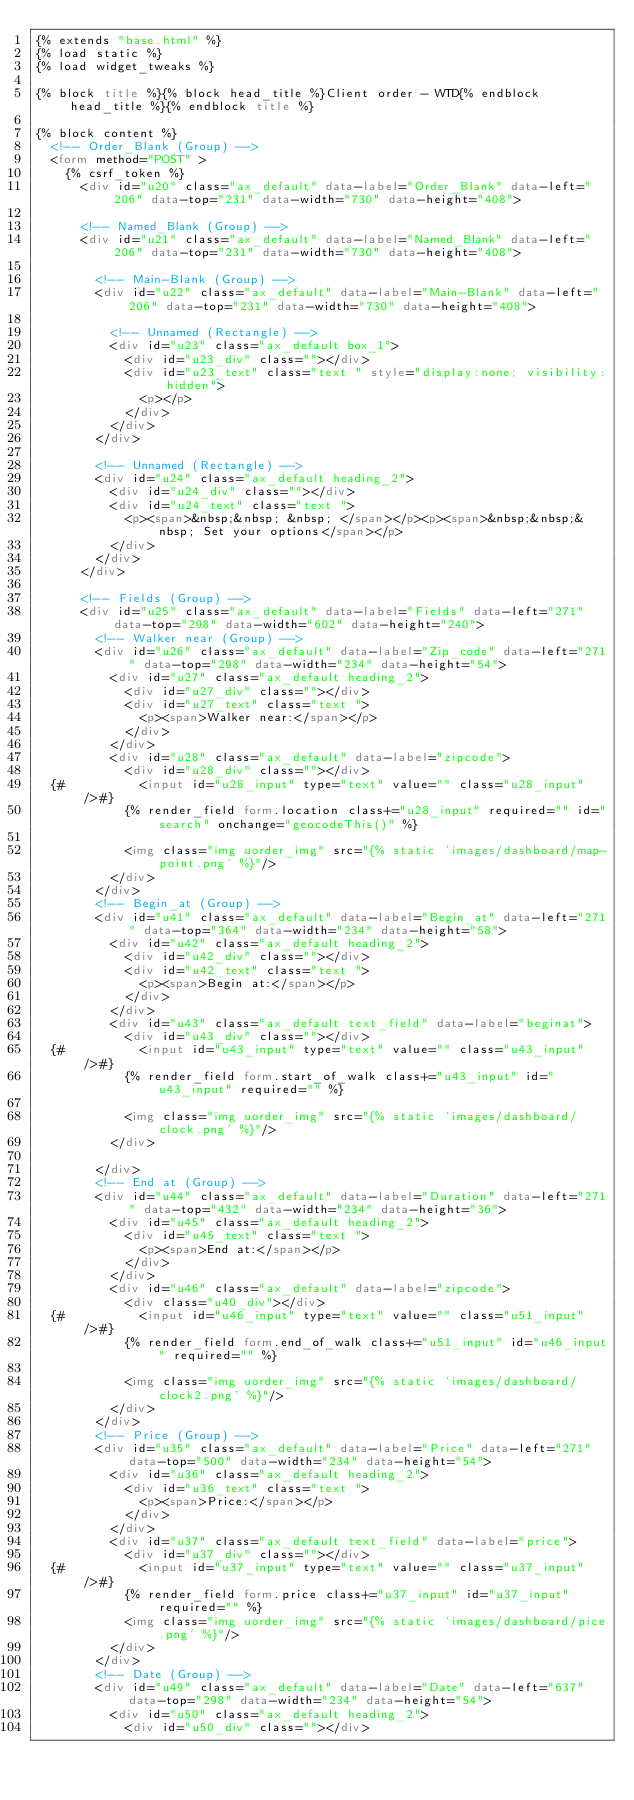Convert code to text. <code><loc_0><loc_0><loc_500><loc_500><_HTML_>{% extends "base.html" %}
{% load static %}
{% load widget_tweaks %}

{% block title %}{% block head_title %}Client order - WTD{% endblock head_title %}{% endblock title %}

{% block content %}
  <!-- Order_Blank (Group) -->
  <form method="POST" >
    {% csrf_token %}
      <div id="u20" class="ax_default" data-label="Order_Blank" data-left="206" data-top="231" data-width="730" data-height="408">

      <!-- Named_Blank (Group) -->
      <div id="u21" class="ax_default" data-label="Named_Blank" data-left="206" data-top="231" data-width="730" data-height="408">

        <!-- Main-Blank (Group) -->
        <div id="u22" class="ax_default" data-label="Main-Blank" data-left="206" data-top="231" data-width="730" data-height="408">

          <!-- Unnamed (Rectangle) -->
          <div id="u23" class="ax_default box_1">
            <div id="u23_div" class=""></div>
            <div id="u23_text" class="text " style="display:none; visibility: hidden">
              <p></p>
            </div>
          </div>
        </div>

        <!-- Unnamed (Rectangle) -->
        <div id="u24" class="ax_default heading_2">
          <div id="u24_div" class=""></div>
          <div id="u24_text" class="text ">
            <p><span>&nbsp;&nbsp; &nbsp; </span></p><p><span>&nbsp;&nbsp;&nbsp; Set your options</span></p>
          </div>
        </div>
      </div>

      <!-- Fields (Group) -->
      <div id="u25" class="ax_default" data-label="Fields" data-left="271" data-top="298" data-width="602" data-height="240">
        <!-- Walker near (Group) -->
        <div id="u26" class="ax_default" data-label="Zip_code" data-left="271" data-top="298" data-width="234" data-height="54">
          <div id="u27" class="ax_default heading_2">
            <div id="u27_div" class=""></div>
            <div id="u27_text" class="text ">
              <p><span>Walker near:</span></p>
            </div>
          </div>
          <div id="u28" class="ax_default" data-label="zipcode">
            <div id="u28_div" class=""></div>
  {#          <input id="u28_input" type="text" value="" class="u28_input"/>#}
            {% render_field form.location class+="u28_input" required="" id="search" onchange="geocodeThis()" %}

            <img class="img uorder_img" src="{% static 'images/dashboard/map-point.png' %}"/>
          </div>
        </div>
        <!-- Begin_at (Group) -->
        <div id="u41" class="ax_default" data-label="Begin_at" data-left="271" data-top="364" data-width="234" data-height="58">
          <div id="u42" class="ax_default heading_2">
            <div id="u42_div" class=""></div>
            <div id="u42_text" class="text ">
              <p><span>Begin at:</span></p>
            </div>
          </div>
          <div id="u43" class="ax_default text_field" data-label="beginat">
            <div id="u43_div" class=""></div>
  {#          <input id="u43_input" type="text" value="" class="u43_input"/>#}
            {% render_field form.start_of_walk class+="u43_input" id="u43_input" required="" %}

            <img class="img uorder_img" src="{% static 'images/dashboard/clock.png' %}"/>
          </div>

        </div>
        <!-- End at (Group) -->
        <div id="u44" class="ax_default" data-label="Duration" data-left="271" data-top="432" data-width="234" data-height="36">
          <div id="u45" class="ax_default heading_2">
            <div id="u45_text" class="text ">
              <p><span>End at:</span></p>
            </div>
          </div>
          <div id="u46" class="ax_default" data-label="zipcode">
            <div class="u40_div"></div>
  {#          <input id="u46_input" type="text" value="" class="u51_input"/>#}
            {% render_field form.end_of_walk class+="u51_input" id="u46_input" required="" %}

            <img class="img uorder_img" src="{% static 'images/dashboard/clock2.png' %}"/>
          </div>
        </div>
        <!-- Price (Group) -->
        <div id="u35" class="ax_default" data-label="Price" data-left="271" data-top="500" data-width="234" data-height="54">
          <div id="u36" class="ax_default heading_2">
            <div id="u36_text" class="text ">
              <p><span>Price:</span></p>
            </div>
          </div>
          <div id="u37" class="ax_default text_field" data-label="price">
            <div id="u37_div" class=""></div>
  {#          <input id="u37_input" type="text" value="" class="u37_input"/>#}
            {% render_field form.price class+="u37_input" id="u37_input" required="" %}
            <img class="img uorder_img" src="{% static 'images/dashboard/pice.png' %}"/>
          </div>
        </div>
        <!-- Date (Group) -->
        <div id="u49" class="ax_default" data-label="Date" data-left="637" data-top="298" data-width="234" data-height="54">
          <div id="u50" class="ax_default heading_2">
            <div id="u50_div" class=""></div></code> 